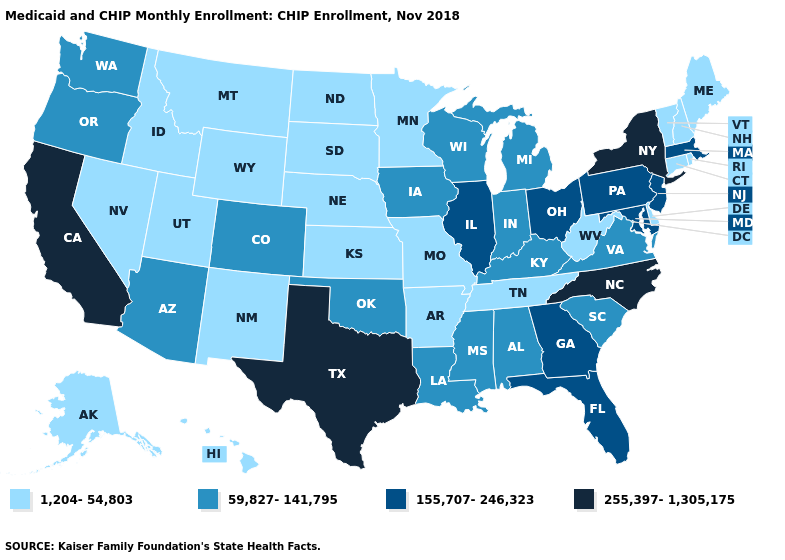What is the value of New Hampshire?
Quick response, please. 1,204-54,803. What is the value of Kansas?
Short answer required. 1,204-54,803. Which states have the highest value in the USA?
Quick response, please. California, New York, North Carolina, Texas. What is the lowest value in the Northeast?
Quick response, please. 1,204-54,803. What is the highest value in the South ?
Give a very brief answer. 255,397-1,305,175. What is the value of New Hampshire?
Quick response, please. 1,204-54,803. Does the first symbol in the legend represent the smallest category?
Quick response, please. Yes. What is the highest value in states that border New Hampshire?
Be succinct. 155,707-246,323. What is the value of North Carolina?
Write a very short answer. 255,397-1,305,175. Does Michigan have a higher value than Nebraska?
Short answer required. Yes. Name the states that have a value in the range 255,397-1,305,175?
Give a very brief answer. California, New York, North Carolina, Texas. What is the value of California?
Concise answer only. 255,397-1,305,175. What is the highest value in the MidWest ?
Keep it brief. 155,707-246,323. What is the value of New Hampshire?
Write a very short answer. 1,204-54,803. Does the map have missing data?
Quick response, please. No. 